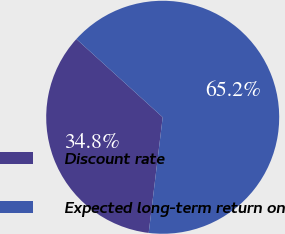Convert chart. <chart><loc_0><loc_0><loc_500><loc_500><pie_chart><fcel>Discount rate<fcel>Expected long-term return on<nl><fcel>34.8%<fcel>65.2%<nl></chart> 